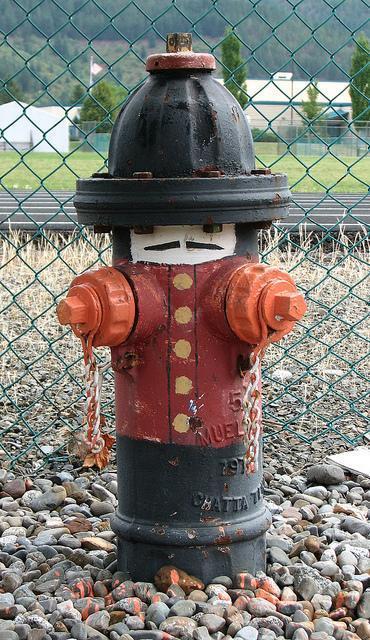How many white horses are there?
Give a very brief answer. 0. 